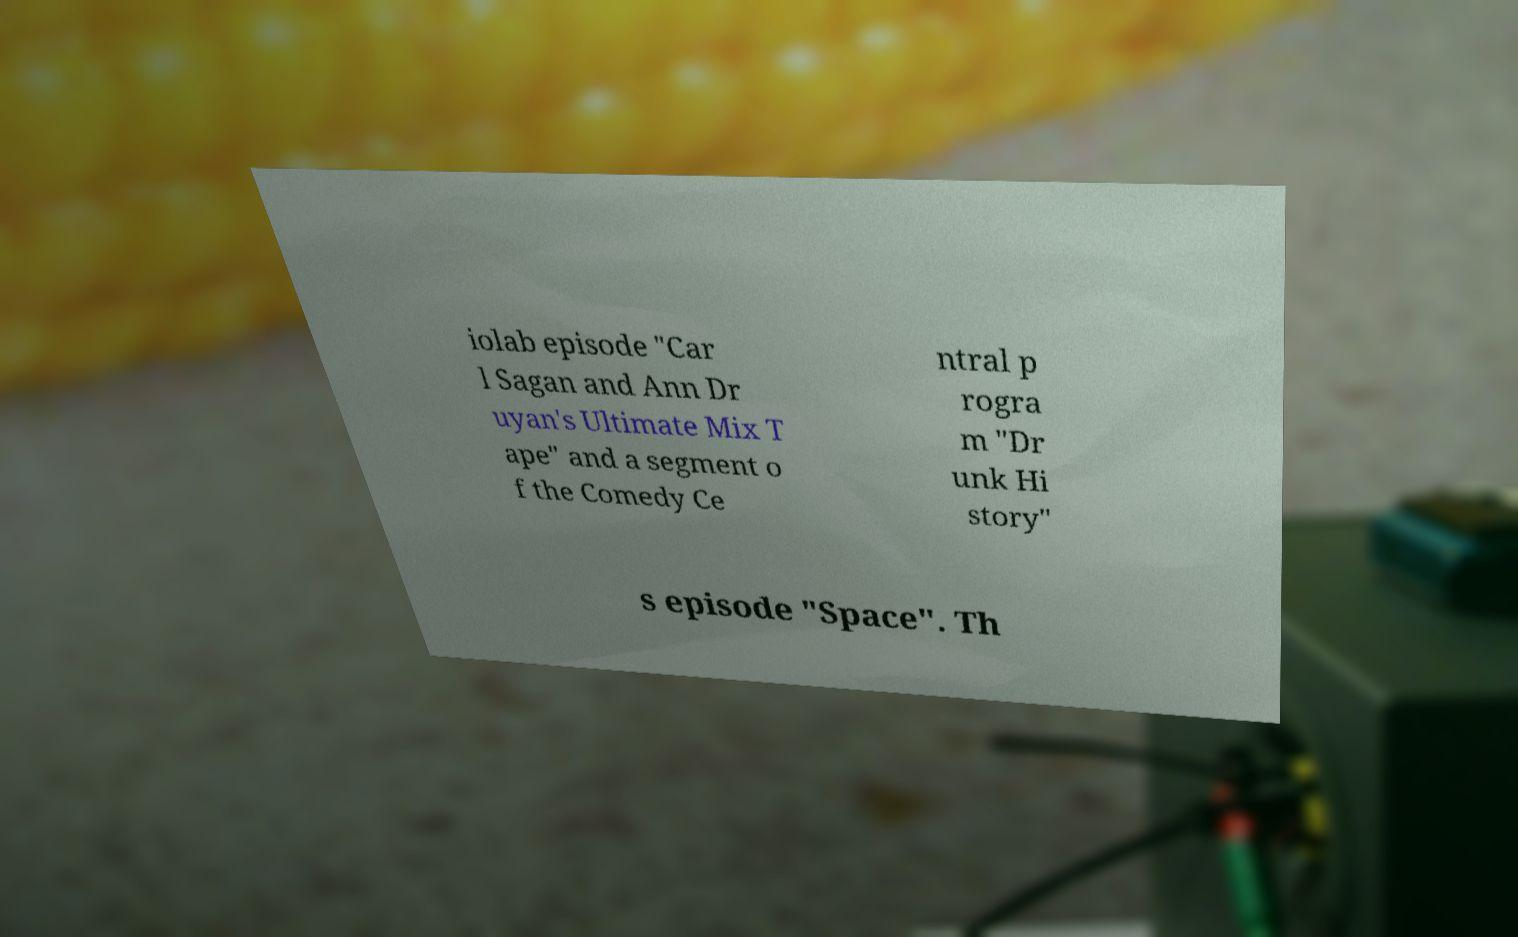Can you accurately transcribe the text from the provided image for me? iolab episode "Car l Sagan and Ann Dr uyan's Ultimate Mix T ape" and a segment o f the Comedy Ce ntral p rogra m "Dr unk Hi story" s episode "Space". Th 